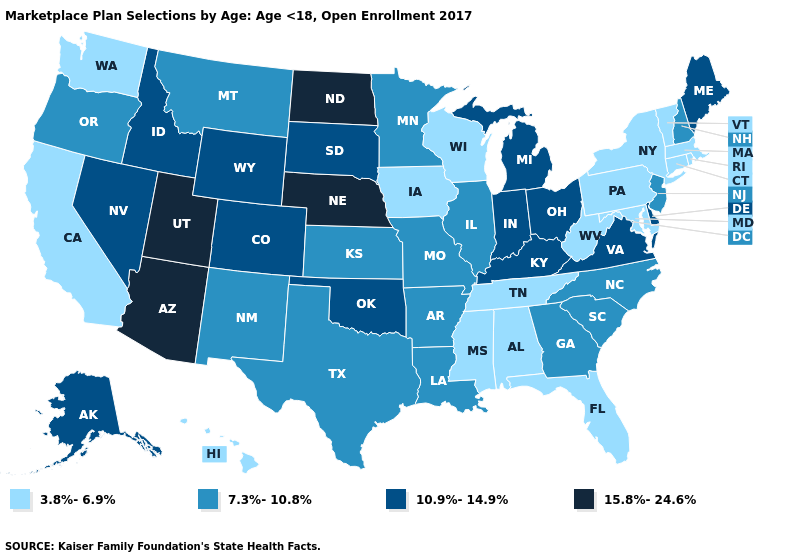Does Oregon have the lowest value in the USA?
Write a very short answer. No. What is the value of Utah?
Answer briefly. 15.8%-24.6%. Does Florida have a higher value than Hawaii?
Write a very short answer. No. Does South Dakota have a lower value than Nebraska?
Keep it brief. Yes. Which states have the lowest value in the Northeast?
Write a very short answer. Connecticut, Massachusetts, New York, Pennsylvania, Rhode Island, Vermont. Which states have the lowest value in the Northeast?
Give a very brief answer. Connecticut, Massachusetts, New York, Pennsylvania, Rhode Island, Vermont. Does Colorado have the highest value in the West?
Concise answer only. No. Name the states that have a value in the range 7.3%-10.8%?
Short answer required. Arkansas, Georgia, Illinois, Kansas, Louisiana, Minnesota, Missouri, Montana, New Hampshire, New Jersey, New Mexico, North Carolina, Oregon, South Carolina, Texas. What is the value of Hawaii?
Keep it brief. 3.8%-6.9%. Name the states that have a value in the range 10.9%-14.9%?
Be succinct. Alaska, Colorado, Delaware, Idaho, Indiana, Kentucky, Maine, Michigan, Nevada, Ohio, Oklahoma, South Dakota, Virginia, Wyoming. Does Alaska have a lower value than North Dakota?
Concise answer only. Yes. Name the states that have a value in the range 15.8%-24.6%?
Give a very brief answer. Arizona, Nebraska, North Dakota, Utah. Which states have the highest value in the USA?
Quick response, please. Arizona, Nebraska, North Dakota, Utah. Does Nebraska have the lowest value in the USA?
Give a very brief answer. No. Name the states that have a value in the range 15.8%-24.6%?
Write a very short answer. Arizona, Nebraska, North Dakota, Utah. 